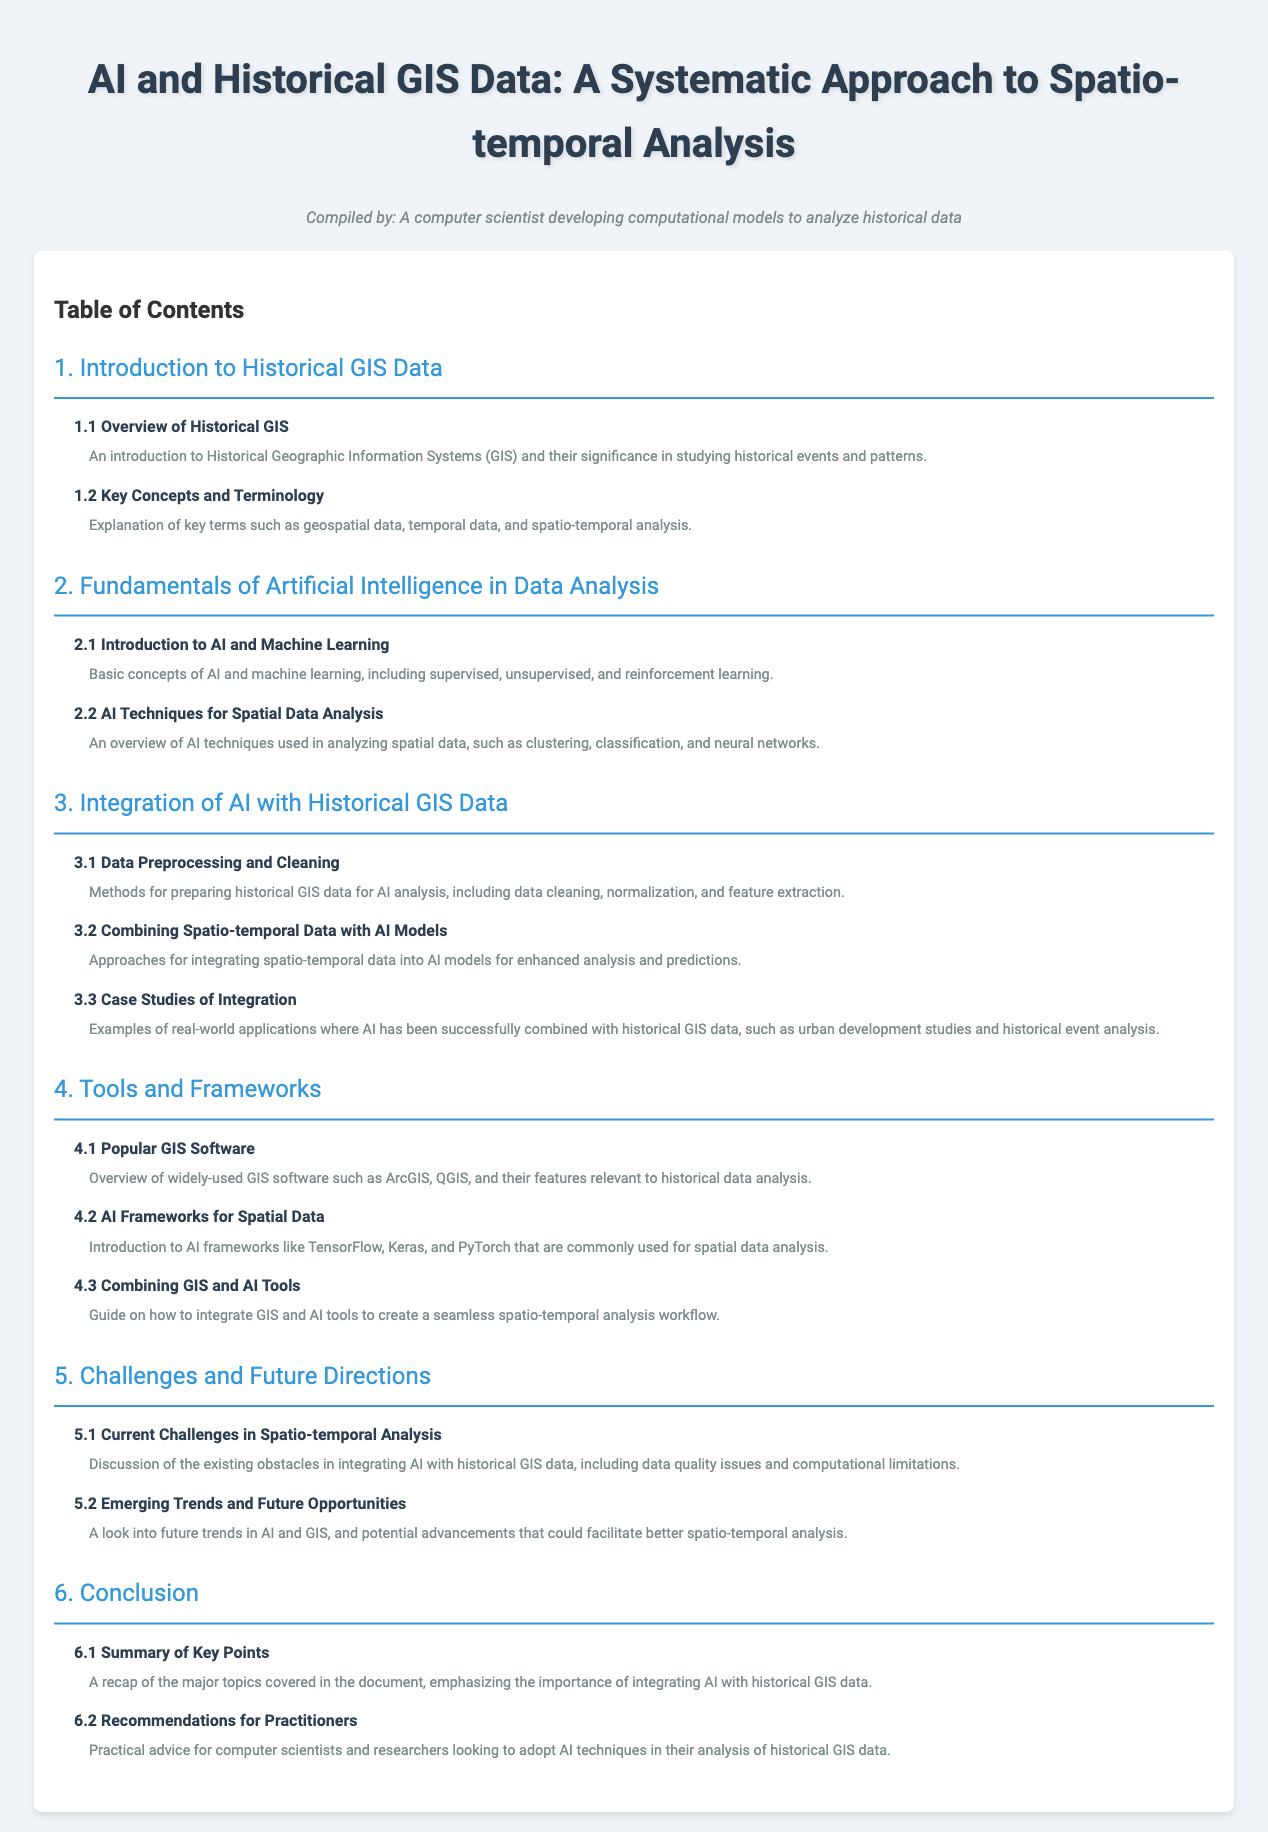what is the title of the document? The title is mentioned in the document as the main heading at the top.
Answer: AI and Historical GIS Data: A Systematic Approach to Spatio-temporal Analysis how many chapters are there in the Table of Contents? The document lists the chapters sequentially in the Table of Contents section.
Answer: 6 what is discussed in section 3.2? Section 3.2 provides information about integrating spatio-temporal data into AI models.
Answer: Combining Spatio-temporal Data with AI Models who compiled this document? The document attributes its compilation to a specific persona, which is noted near the title.
Answer: A computer scientist developing computational models to analyze historical data what is the focus of chapter 5? Chapter 5 addresses the challenges and future directions related to the main topic of the document.
Answer: Challenges and Future Directions what type of analysis is emphasized in the document? The analysis being highlighted throughout the document involves studying historical data with a specific technique.
Answer: Spatio-temporal Analysis which AI frameworks are mentioned in section 4.2? Section 4.2 introduces specific AI frameworks commonly used for spatial data analysis.
Answer: TensorFlow, Keras, and PyTorch what does section 6.2 provide for practitioners? Section 6.2 offers specific guidance geared toward a group of individuals engaged in the document's subject matter.
Answer: Recommendations for Practitioners 